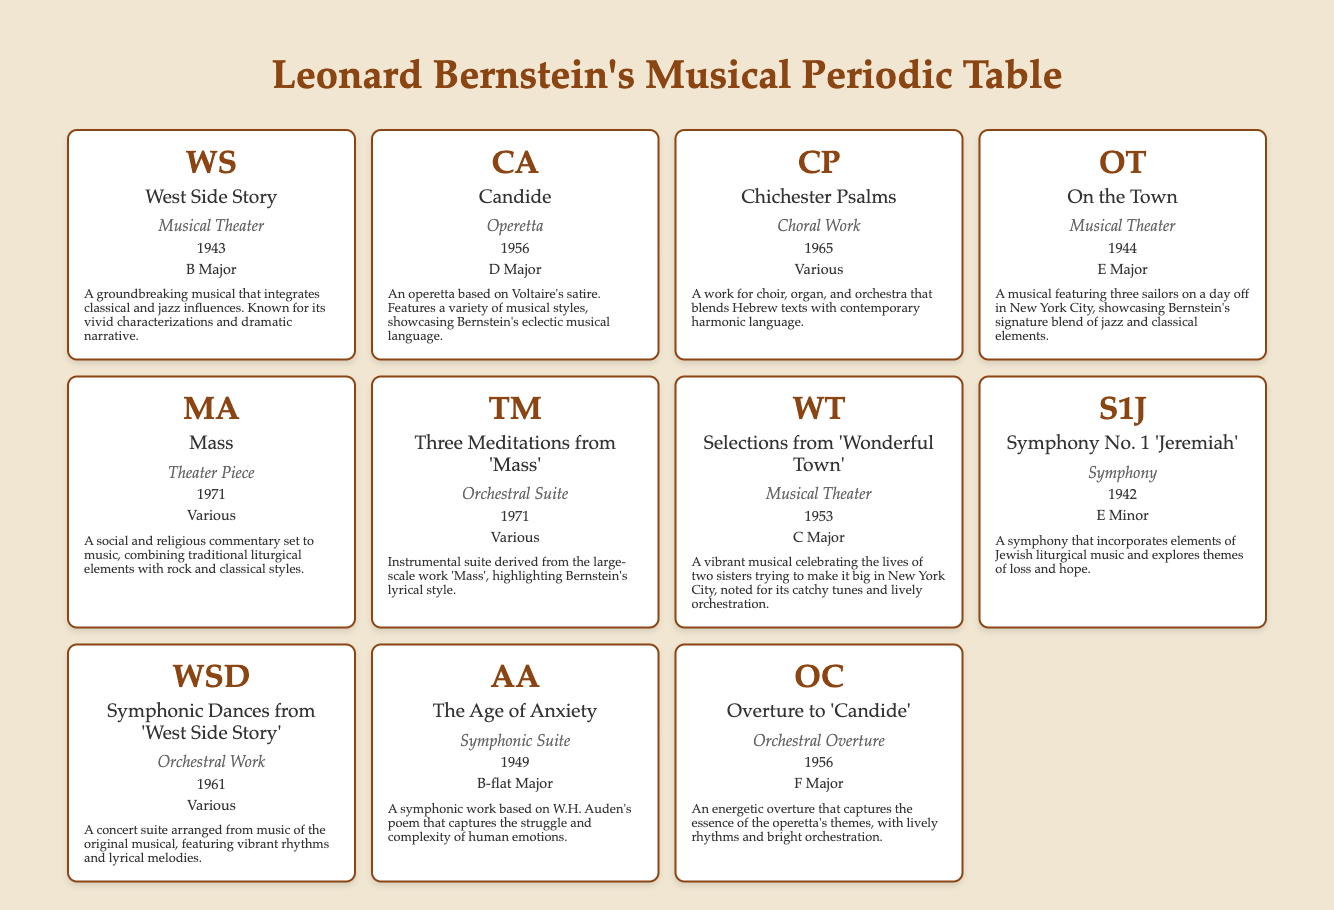What is the key signature of "West Side Story"? The table indicates that "West Side Story" has a key signature of B Major. This information can be found directly in the relevant row under the key signature column.
Answer: B Major Which work was composed in 1965? According to the table, "Chichester Psalms" is the only work listed that was composed in 1965, as indicated in the years composed column of that row.
Answer: Chichester Psalms How many pieces fall under the category of Musical Theater? The table shows four works listed under the category of Musical Theater: "West Side Story," "On the Town," "Selections from 'Wonderful Town'," and "Candide." To find the count, simply tally the applicable entries.
Answer: 4 Was "Symphony No. 1 'Jeremiah'" composed before 1950? Looking at the years composed column for "Symphony No. 1 'Jeremiah'", it is shown to have been composed in 1942. Therefore, it was indeed composed before 1950.
Answer: Yes What is the average year of composition for Bernstein's works listed? The years of composition for the listed works are: 1942, 1943, 1944, 1949, 1953, 1956, 1961, 1965, and 1971. Calculating the average: (1942 + 1943 + 1944 + 1949 + 1953 + 1956 + 1961 + 1965 + 1971) = 17500. There are 9 works, so divide the total by 9 to get: 17500/9 = 1944.44, which rounds to 1944.
Answer: 1944 How many works have various key signatures? Examining the table, "Chichester Psalms," "Mass," "Three Meditations from 'Mass'," and "Symphonic Dances from 'West Side Story'" are the four works that list "Various" as their key signature. Counting them gives a total of 4.
Answer: 4 Is "The Age of Anxiety" an orchestral work? Referring to the category column in the table, "The Age of Anxiety" is classified as a Symphonic Suite, not under orchestral works. Therefore, the statement is false.
Answer: No Which work has the notes indicating a blend of Hebrew texts with contemporary harmonic language? According to the notes column, "Chichester Psalms" is noted for blending Hebrew texts with contemporary harmonic language. It can be found directly in the row for this work.
Answer: Chichester Psalms 